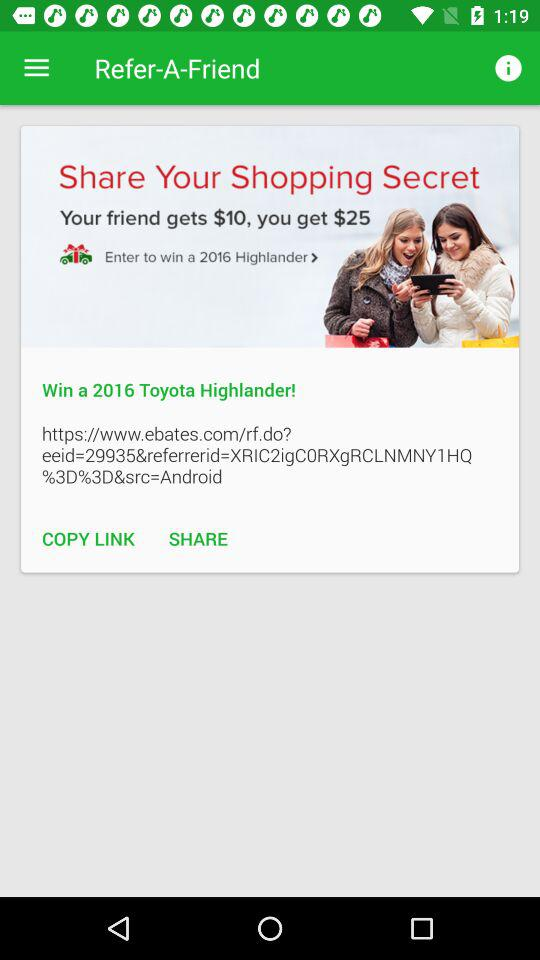How much money will my friend get? Your friend will get $10. 